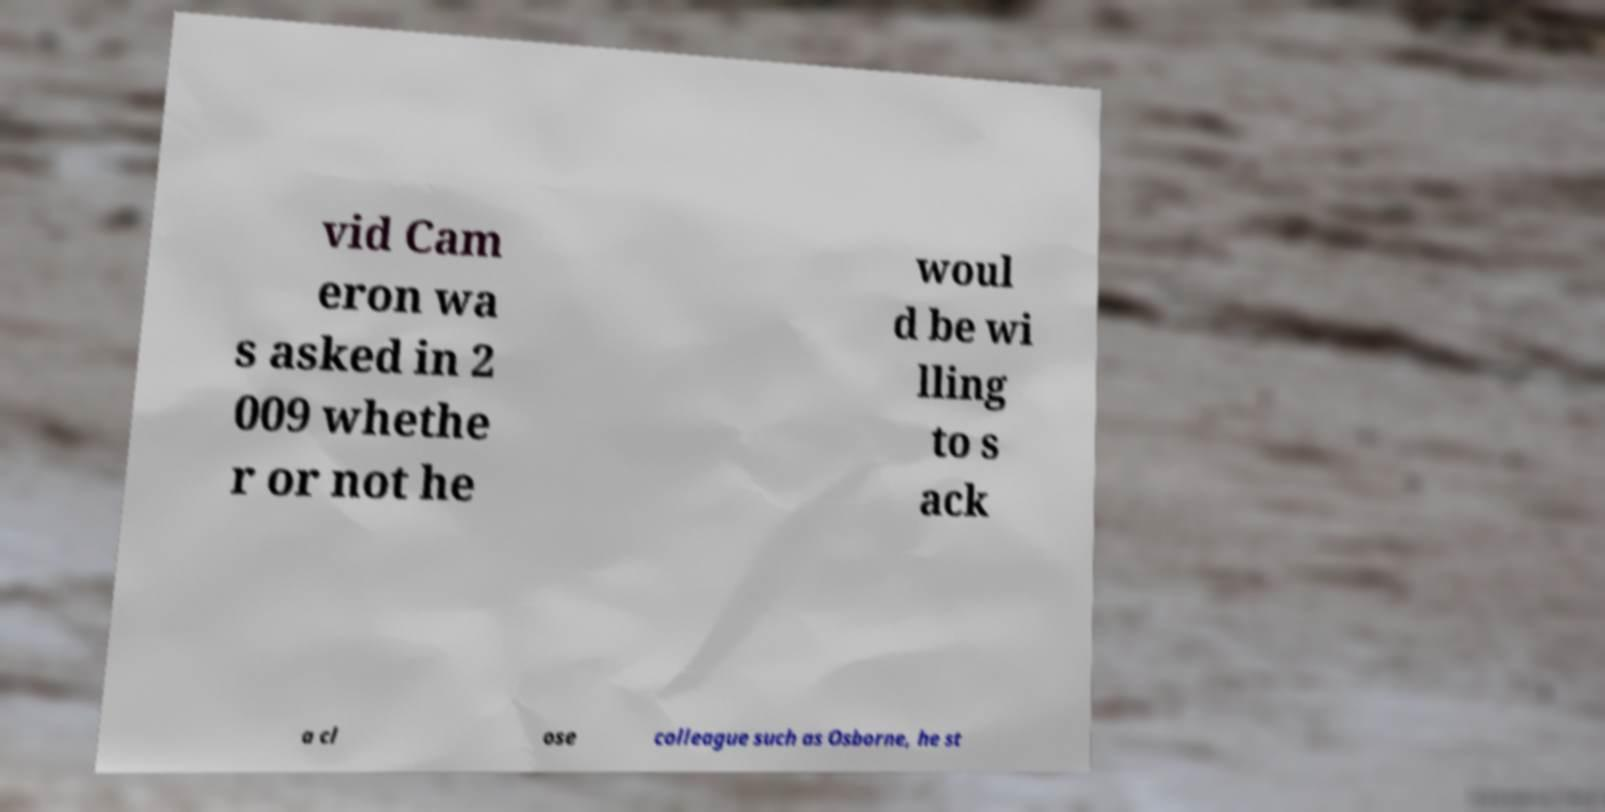I need the written content from this picture converted into text. Can you do that? vid Cam eron wa s asked in 2 009 whethe r or not he woul d be wi lling to s ack a cl ose colleague such as Osborne, he st 